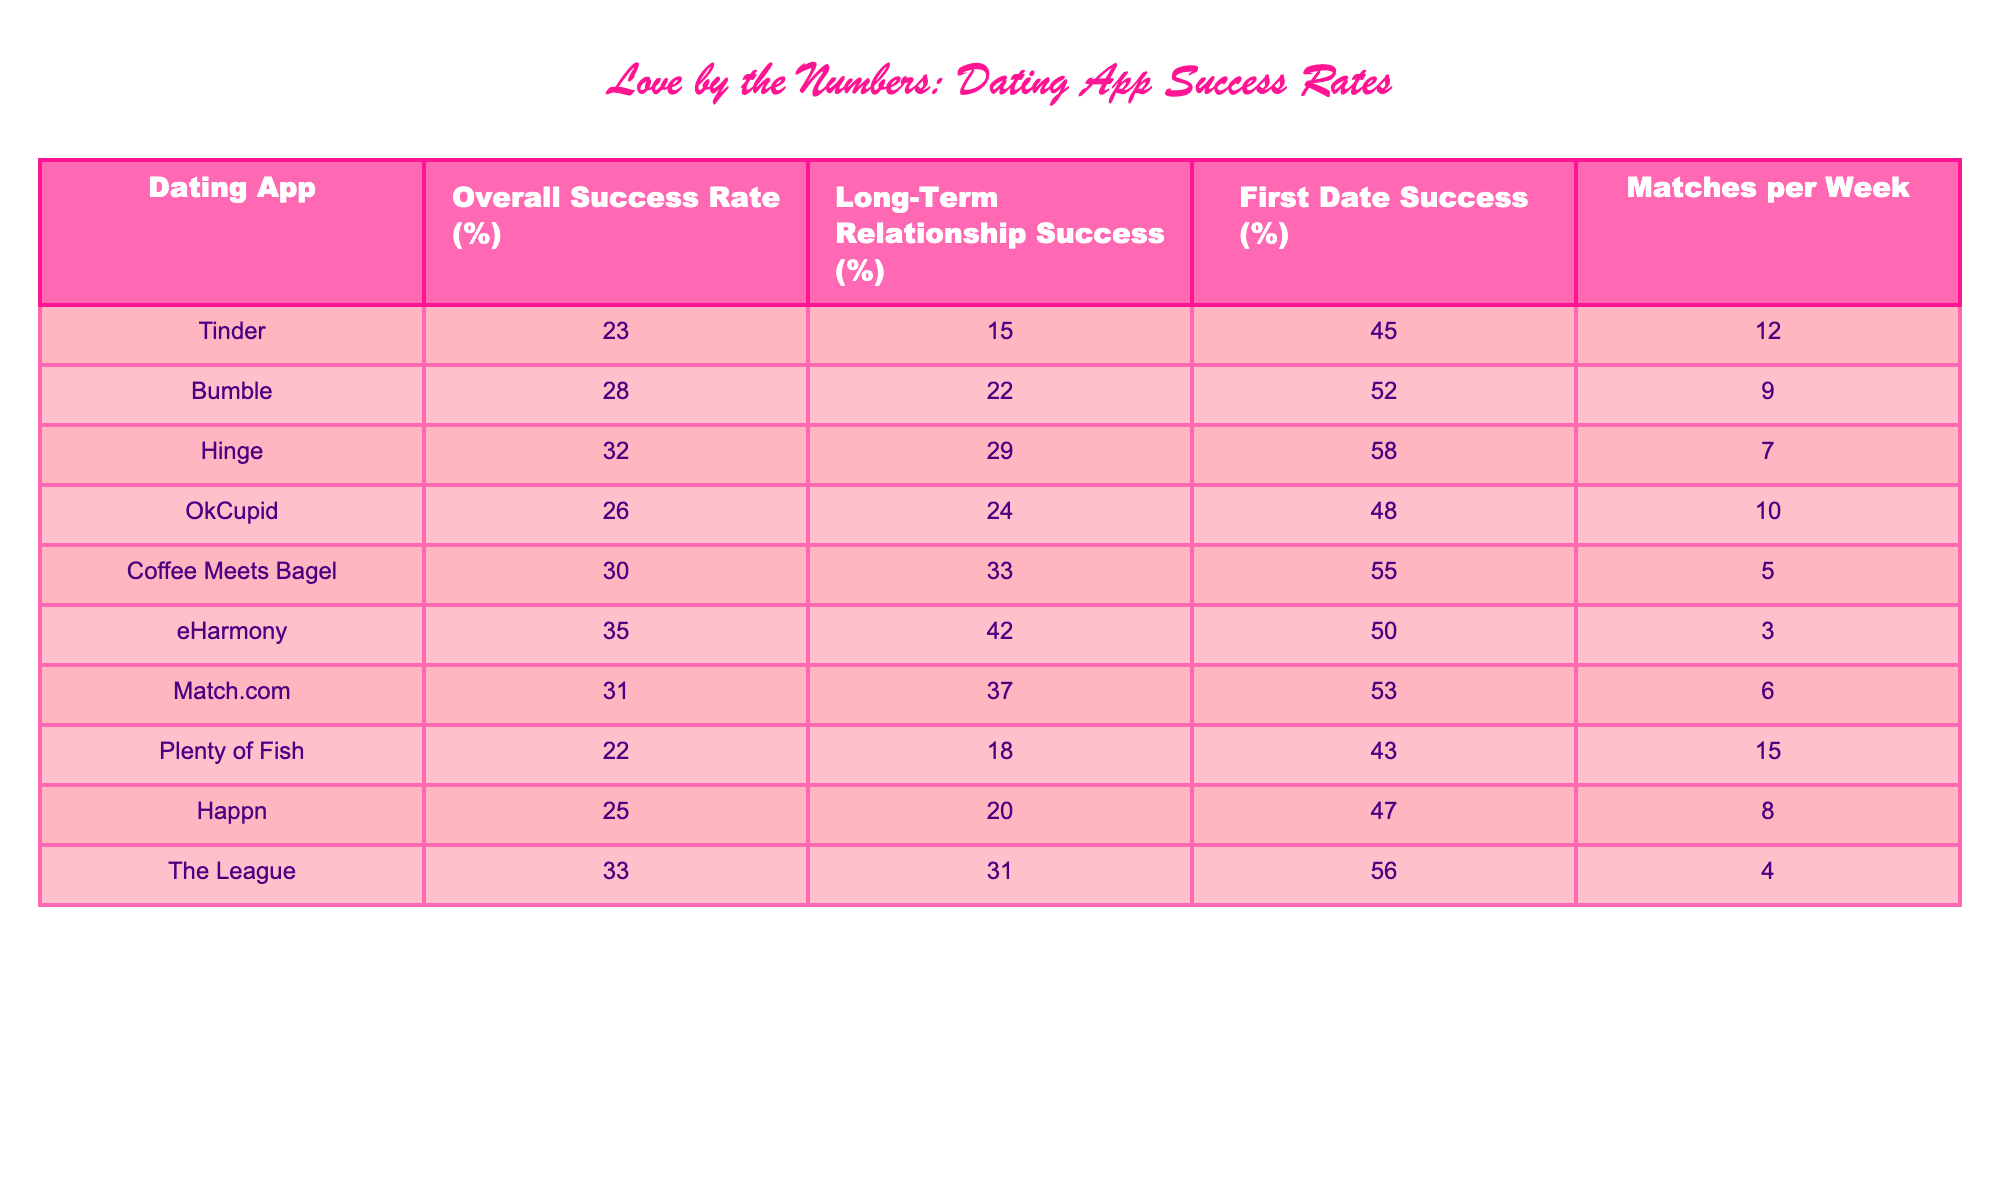What is the overall success rate for Bumble? The table lists Bumble's overall success rate, which is stated in the corresponding row. It shows that Bumble has an overall success rate of 28%.
Answer: 28% Which dating app has the highest first date success rate? By reviewing the first date success rate column, I can identify that Hinge has the highest first date success rate at 58%.
Answer: Hinge What is the average matches per week across all dating apps? To find the average, I add the matches per week for all dating apps: (12 + 9 + 7 + 10 + 5 + 3 + 6 + 15 + 8 + 4) = 69, and then divide by the number of apps (10): 69 / 10 = 6.9.
Answer: 6.9 Is it true that eHarmony has a higher long-term relationship success rate than Coffee Meets Bagel? By comparing the long-term relationship success rates, eHarmony has a rate of 42% while Coffee Meets Bagel has a rate of 33%. Since 42% is greater than 33%, the statement is true.
Answer: Yes What is the difference in overall success rate between the app with the highest and lowest rates? The highest overall success rate is 35% (eHarmony), and the lowest is 22% (Plenty of Fish). The difference is calculated by subtracting the lowest from the highest: 35% - 22% = 13%.
Answer: 13% Which app has both a first date and long-term relationship success rate higher than 50%? By looking at the first date and long-term relationship success rates, only eHarmony has a long-term relationship success of 42% but its first date success rate is 50%. Coffee Meets Bagel has both at 55% (first date) and long-term of 33%. Therefore, the answer is no app meets both criteria.
Answer: None Is there a dating app where the first date success rate is lower than the overall success rate? By checking the first date success rates compared to their overall success rates, I find that Plenty of Fish has a first date success of 43% and an overall success rate of 22%, which means its first date success rate is indeed higher, but several others, like Tinder (45% vs. 23%), also shows it is lower than the overall rate.
Answer: Yes What is the ratio of the overall success rates between Hinge and Tinder? Hinge has an overall success rate of 32%, and Tinder has a rate of 23%. The ratio is calculated by dividing Hinge's rate by Tinder's rate: 32% / 23% = 1.39.
Answer: 1.39 